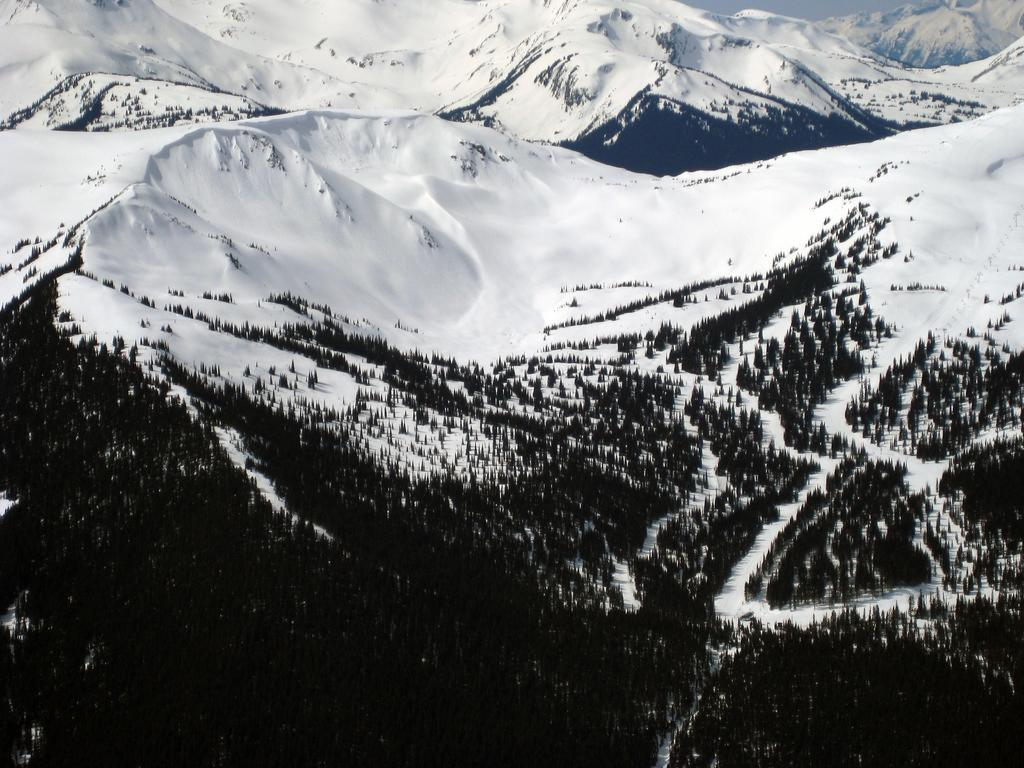What type of view is provided in the image? The image is an aerial view of a place. What natural elements can be seen in the image? There are trees and snow visible in the image. What geographical feature is present in the image? There are mountains visible in the image. Where is the bucket placed in the image? There is no bucket present in the image. What type of cloth is draped over the trees in the image? There is no cloth draped over the trees in the image. 